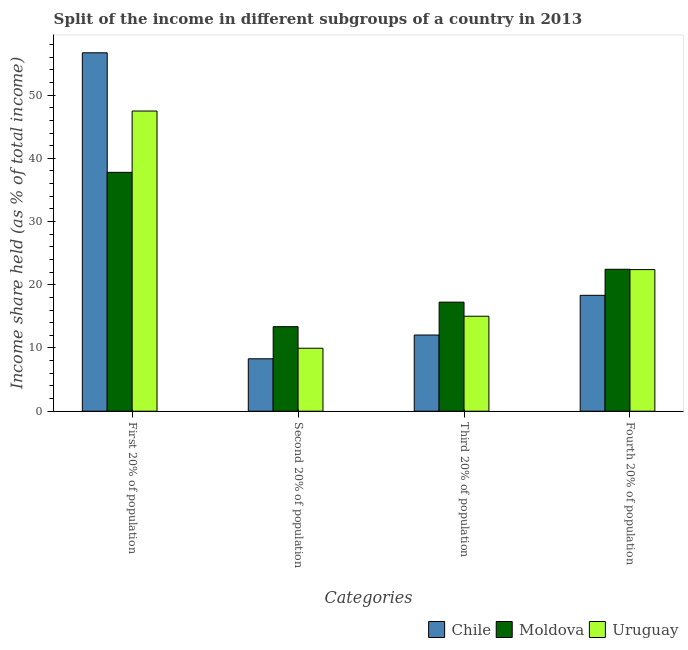Are the number of bars per tick equal to the number of legend labels?
Provide a succinct answer. Yes. How many bars are there on the 3rd tick from the left?
Make the answer very short. 3. What is the label of the 4th group of bars from the left?
Ensure brevity in your answer.  Fourth 20% of population. What is the share of the income held by first 20% of the population in Uruguay?
Offer a very short reply. 47.48. Across all countries, what is the maximum share of the income held by second 20% of the population?
Offer a terse response. 13.37. Across all countries, what is the minimum share of the income held by first 20% of the population?
Provide a short and direct response. 37.78. In which country was the share of the income held by fourth 20% of the population maximum?
Ensure brevity in your answer.  Moldova. In which country was the share of the income held by fourth 20% of the population minimum?
Give a very brief answer. Chile. What is the total share of the income held by fourth 20% of the population in the graph?
Your answer should be very brief. 63.18. What is the difference between the share of the income held by fourth 20% of the population in Chile and that in Uruguay?
Make the answer very short. -4.07. What is the difference between the share of the income held by fourth 20% of the population in Moldova and the share of the income held by first 20% of the population in Chile?
Your response must be concise. -34.24. What is the average share of the income held by first 20% of the population per country?
Offer a terse response. 47.32. What is the difference between the share of the income held by first 20% of the population and share of the income held by second 20% of the population in Chile?
Give a very brief answer. 48.4. In how many countries, is the share of the income held by second 20% of the population greater than 34 %?
Offer a very short reply. 0. What is the ratio of the share of the income held by first 20% of the population in Uruguay to that in Chile?
Provide a short and direct response. 0.84. Is the share of the income held by first 20% of the population in Chile less than that in Uruguay?
Provide a short and direct response. No. What is the difference between the highest and the second highest share of the income held by second 20% of the population?
Your answer should be compact. 3.41. What is the difference between the highest and the lowest share of the income held by first 20% of the population?
Your answer should be compact. 18.91. In how many countries, is the share of the income held by third 20% of the population greater than the average share of the income held by third 20% of the population taken over all countries?
Offer a very short reply. 2. Is it the case that in every country, the sum of the share of the income held by fourth 20% of the population and share of the income held by third 20% of the population is greater than the sum of share of the income held by second 20% of the population and share of the income held by first 20% of the population?
Offer a very short reply. No. What does the 3rd bar from the left in Second 20% of population represents?
Make the answer very short. Uruguay. What does the 2nd bar from the right in Fourth 20% of population represents?
Keep it short and to the point. Moldova. Is it the case that in every country, the sum of the share of the income held by first 20% of the population and share of the income held by second 20% of the population is greater than the share of the income held by third 20% of the population?
Provide a succinct answer. Yes. How many bars are there?
Keep it short and to the point. 12. Are all the bars in the graph horizontal?
Your answer should be compact. No. How many countries are there in the graph?
Offer a very short reply. 3. What is the difference between two consecutive major ticks on the Y-axis?
Provide a succinct answer. 10. Are the values on the major ticks of Y-axis written in scientific E-notation?
Your response must be concise. No. Where does the legend appear in the graph?
Keep it short and to the point. Bottom right. How many legend labels are there?
Your answer should be compact. 3. How are the legend labels stacked?
Provide a succinct answer. Horizontal. What is the title of the graph?
Give a very brief answer. Split of the income in different subgroups of a country in 2013. Does "Tonga" appear as one of the legend labels in the graph?
Give a very brief answer. No. What is the label or title of the X-axis?
Offer a terse response. Categories. What is the label or title of the Y-axis?
Your answer should be compact. Income share held (as % of total income). What is the Income share held (as % of total income) in Chile in First 20% of population?
Ensure brevity in your answer.  56.69. What is the Income share held (as % of total income) of Moldova in First 20% of population?
Your answer should be compact. 37.78. What is the Income share held (as % of total income) in Uruguay in First 20% of population?
Keep it short and to the point. 47.48. What is the Income share held (as % of total income) of Chile in Second 20% of population?
Your answer should be compact. 8.29. What is the Income share held (as % of total income) in Moldova in Second 20% of population?
Ensure brevity in your answer.  13.37. What is the Income share held (as % of total income) of Uruguay in Second 20% of population?
Provide a short and direct response. 9.96. What is the Income share held (as % of total income) in Chile in Third 20% of population?
Your response must be concise. 12.05. What is the Income share held (as % of total income) of Moldova in Third 20% of population?
Offer a terse response. 17.25. What is the Income share held (as % of total income) of Uruguay in Third 20% of population?
Keep it short and to the point. 15.02. What is the Income share held (as % of total income) of Chile in Fourth 20% of population?
Make the answer very short. 18.33. What is the Income share held (as % of total income) in Moldova in Fourth 20% of population?
Offer a terse response. 22.45. What is the Income share held (as % of total income) in Uruguay in Fourth 20% of population?
Your answer should be compact. 22.4. Across all Categories, what is the maximum Income share held (as % of total income) in Chile?
Give a very brief answer. 56.69. Across all Categories, what is the maximum Income share held (as % of total income) in Moldova?
Give a very brief answer. 37.78. Across all Categories, what is the maximum Income share held (as % of total income) of Uruguay?
Provide a succinct answer. 47.48. Across all Categories, what is the minimum Income share held (as % of total income) in Chile?
Offer a very short reply. 8.29. Across all Categories, what is the minimum Income share held (as % of total income) in Moldova?
Offer a terse response. 13.37. Across all Categories, what is the minimum Income share held (as % of total income) in Uruguay?
Provide a succinct answer. 9.96. What is the total Income share held (as % of total income) of Chile in the graph?
Offer a terse response. 95.36. What is the total Income share held (as % of total income) of Moldova in the graph?
Give a very brief answer. 90.85. What is the total Income share held (as % of total income) in Uruguay in the graph?
Offer a very short reply. 94.86. What is the difference between the Income share held (as % of total income) of Chile in First 20% of population and that in Second 20% of population?
Provide a short and direct response. 48.4. What is the difference between the Income share held (as % of total income) in Moldova in First 20% of population and that in Second 20% of population?
Your response must be concise. 24.41. What is the difference between the Income share held (as % of total income) of Uruguay in First 20% of population and that in Second 20% of population?
Ensure brevity in your answer.  37.52. What is the difference between the Income share held (as % of total income) in Chile in First 20% of population and that in Third 20% of population?
Ensure brevity in your answer.  44.64. What is the difference between the Income share held (as % of total income) in Moldova in First 20% of population and that in Third 20% of population?
Offer a very short reply. 20.53. What is the difference between the Income share held (as % of total income) in Uruguay in First 20% of population and that in Third 20% of population?
Your answer should be very brief. 32.46. What is the difference between the Income share held (as % of total income) of Chile in First 20% of population and that in Fourth 20% of population?
Offer a terse response. 38.36. What is the difference between the Income share held (as % of total income) in Moldova in First 20% of population and that in Fourth 20% of population?
Provide a short and direct response. 15.33. What is the difference between the Income share held (as % of total income) in Uruguay in First 20% of population and that in Fourth 20% of population?
Provide a short and direct response. 25.08. What is the difference between the Income share held (as % of total income) of Chile in Second 20% of population and that in Third 20% of population?
Your answer should be very brief. -3.76. What is the difference between the Income share held (as % of total income) in Moldova in Second 20% of population and that in Third 20% of population?
Provide a short and direct response. -3.88. What is the difference between the Income share held (as % of total income) in Uruguay in Second 20% of population and that in Third 20% of population?
Ensure brevity in your answer.  -5.06. What is the difference between the Income share held (as % of total income) in Chile in Second 20% of population and that in Fourth 20% of population?
Offer a terse response. -10.04. What is the difference between the Income share held (as % of total income) in Moldova in Second 20% of population and that in Fourth 20% of population?
Offer a terse response. -9.08. What is the difference between the Income share held (as % of total income) of Uruguay in Second 20% of population and that in Fourth 20% of population?
Provide a succinct answer. -12.44. What is the difference between the Income share held (as % of total income) in Chile in Third 20% of population and that in Fourth 20% of population?
Offer a very short reply. -6.28. What is the difference between the Income share held (as % of total income) of Moldova in Third 20% of population and that in Fourth 20% of population?
Your answer should be very brief. -5.2. What is the difference between the Income share held (as % of total income) of Uruguay in Third 20% of population and that in Fourth 20% of population?
Ensure brevity in your answer.  -7.38. What is the difference between the Income share held (as % of total income) in Chile in First 20% of population and the Income share held (as % of total income) in Moldova in Second 20% of population?
Give a very brief answer. 43.32. What is the difference between the Income share held (as % of total income) of Chile in First 20% of population and the Income share held (as % of total income) of Uruguay in Second 20% of population?
Provide a short and direct response. 46.73. What is the difference between the Income share held (as % of total income) in Moldova in First 20% of population and the Income share held (as % of total income) in Uruguay in Second 20% of population?
Your answer should be very brief. 27.82. What is the difference between the Income share held (as % of total income) of Chile in First 20% of population and the Income share held (as % of total income) of Moldova in Third 20% of population?
Offer a terse response. 39.44. What is the difference between the Income share held (as % of total income) in Chile in First 20% of population and the Income share held (as % of total income) in Uruguay in Third 20% of population?
Your response must be concise. 41.67. What is the difference between the Income share held (as % of total income) of Moldova in First 20% of population and the Income share held (as % of total income) of Uruguay in Third 20% of population?
Give a very brief answer. 22.76. What is the difference between the Income share held (as % of total income) of Chile in First 20% of population and the Income share held (as % of total income) of Moldova in Fourth 20% of population?
Offer a terse response. 34.24. What is the difference between the Income share held (as % of total income) of Chile in First 20% of population and the Income share held (as % of total income) of Uruguay in Fourth 20% of population?
Ensure brevity in your answer.  34.29. What is the difference between the Income share held (as % of total income) of Moldova in First 20% of population and the Income share held (as % of total income) of Uruguay in Fourth 20% of population?
Ensure brevity in your answer.  15.38. What is the difference between the Income share held (as % of total income) of Chile in Second 20% of population and the Income share held (as % of total income) of Moldova in Third 20% of population?
Your answer should be very brief. -8.96. What is the difference between the Income share held (as % of total income) in Chile in Second 20% of population and the Income share held (as % of total income) in Uruguay in Third 20% of population?
Make the answer very short. -6.73. What is the difference between the Income share held (as % of total income) of Moldova in Second 20% of population and the Income share held (as % of total income) of Uruguay in Third 20% of population?
Give a very brief answer. -1.65. What is the difference between the Income share held (as % of total income) of Chile in Second 20% of population and the Income share held (as % of total income) of Moldova in Fourth 20% of population?
Offer a very short reply. -14.16. What is the difference between the Income share held (as % of total income) of Chile in Second 20% of population and the Income share held (as % of total income) of Uruguay in Fourth 20% of population?
Offer a very short reply. -14.11. What is the difference between the Income share held (as % of total income) of Moldova in Second 20% of population and the Income share held (as % of total income) of Uruguay in Fourth 20% of population?
Provide a short and direct response. -9.03. What is the difference between the Income share held (as % of total income) in Chile in Third 20% of population and the Income share held (as % of total income) in Moldova in Fourth 20% of population?
Provide a short and direct response. -10.4. What is the difference between the Income share held (as % of total income) of Chile in Third 20% of population and the Income share held (as % of total income) of Uruguay in Fourth 20% of population?
Ensure brevity in your answer.  -10.35. What is the difference between the Income share held (as % of total income) in Moldova in Third 20% of population and the Income share held (as % of total income) in Uruguay in Fourth 20% of population?
Your response must be concise. -5.15. What is the average Income share held (as % of total income) in Chile per Categories?
Provide a succinct answer. 23.84. What is the average Income share held (as % of total income) of Moldova per Categories?
Your answer should be very brief. 22.71. What is the average Income share held (as % of total income) in Uruguay per Categories?
Your answer should be very brief. 23.71. What is the difference between the Income share held (as % of total income) of Chile and Income share held (as % of total income) of Moldova in First 20% of population?
Keep it short and to the point. 18.91. What is the difference between the Income share held (as % of total income) in Chile and Income share held (as % of total income) in Uruguay in First 20% of population?
Keep it short and to the point. 9.21. What is the difference between the Income share held (as % of total income) of Chile and Income share held (as % of total income) of Moldova in Second 20% of population?
Provide a short and direct response. -5.08. What is the difference between the Income share held (as % of total income) of Chile and Income share held (as % of total income) of Uruguay in Second 20% of population?
Ensure brevity in your answer.  -1.67. What is the difference between the Income share held (as % of total income) of Moldova and Income share held (as % of total income) of Uruguay in Second 20% of population?
Offer a very short reply. 3.41. What is the difference between the Income share held (as % of total income) of Chile and Income share held (as % of total income) of Uruguay in Third 20% of population?
Offer a very short reply. -2.97. What is the difference between the Income share held (as % of total income) in Moldova and Income share held (as % of total income) in Uruguay in Third 20% of population?
Provide a short and direct response. 2.23. What is the difference between the Income share held (as % of total income) of Chile and Income share held (as % of total income) of Moldova in Fourth 20% of population?
Offer a terse response. -4.12. What is the difference between the Income share held (as % of total income) of Chile and Income share held (as % of total income) of Uruguay in Fourth 20% of population?
Make the answer very short. -4.07. What is the difference between the Income share held (as % of total income) of Moldova and Income share held (as % of total income) of Uruguay in Fourth 20% of population?
Provide a succinct answer. 0.05. What is the ratio of the Income share held (as % of total income) of Chile in First 20% of population to that in Second 20% of population?
Your answer should be very brief. 6.84. What is the ratio of the Income share held (as % of total income) of Moldova in First 20% of population to that in Second 20% of population?
Make the answer very short. 2.83. What is the ratio of the Income share held (as % of total income) of Uruguay in First 20% of population to that in Second 20% of population?
Provide a succinct answer. 4.77. What is the ratio of the Income share held (as % of total income) of Chile in First 20% of population to that in Third 20% of population?
Keep it short and to the point. 4.7. What is the ratio of the Income share held (as % of total income) in Moldova in First 20% of population to that in Third 20% of population?
Give a very brief answer. 2.19. What is the ratio of the Income share held (as % of total income) in Uruguay in First 20% of population to that in Third 20% of population?
Offer a very short reply. 3.16. What is the ratio of the Income share held (as % of total income) in Chile in First 20% of population to that in Fourth 20% of population?
Ensure brevity in your answer.  3.09. What is the ratio of the Income share held (as % of total income) of Moldova in First 20% of population to that in Fourth 20% of population?
Your answer should be very brief. 1.68. What is the ratio of the Income share held (as % of total income) in Uruguay in First 20% of population to that in Fourth 20% of population?
Offer a very short reply. 2.12. What is the ratio of the Income share held (as % of total income) of Chile in Second 20% of population to that in Third 20% of population?
Your answer should be compact. 0.69. What is the ratio of the Income share held (as % of total income) of Moldova in Second 20% of population to that in Third 20% of population?
Provide a succinct answer. 0.78. What is the ratio of the Income share held (as % of total income) of Uruguay in Second 20% of population to that in Third 20% of population?
Make the answer very short. 0.66. What is the ratio of the Income share held (as % of total income) in Chile in Second 20% of population to that in Fourth 20% of population?
Keep it short and to the point. 0.45. What is the ratio of the Income share held (as % of total income) in Moldova in Second 20% of population to that in Fourth 20% of population?
Keep it short and to the point. 0.6. What is the ratio of the Income share held (as % of total income) in Uruguay in Second 20% of population to that in Fourth 20% of population?
Give a very brief answer. 0.44. What is the ratio of the Income share held (as % of total income) of Chile in Third 20% of population to that in Fourth 20% of population?
Offer a terse response. 0.66. What is the ratio of the Income share held (as % of total income) of Moldova in Third 20% of population to that in Fourth 20% of population?
Your answer should be compact. 0.77. What is the ratio of the Income share held (as % of total income) of Uruguay in Third 20% of population to that in Fourth 20% of population?
Provide a short and direct response. 0.67. What is the difference between the highest and the second highest Income share held (as % of total income) in Chile?
Keep it short and to the point. 38.36. What is the difference between the highest and the second highest Income share held (as % of total income) in Moldova?
Your answer should be compact. 15.33. What is the difference between the highest and the second highest Income share held (as % of total income) in Uruguay?
Offer a terse response. 25.08. What is the difference between the highest and the lowest Income share held (as % of total income) in Chile?
Your answer should be compact. 48.4. What is the difference between the highest and the lowest Income share held (as % of total income) of Moldova?
Offer a very short reply. 24.41. What is the difference between the highest and the lowest Income share held (as % of total income) in Uruguay?
Offer a terse response. 37.52. 